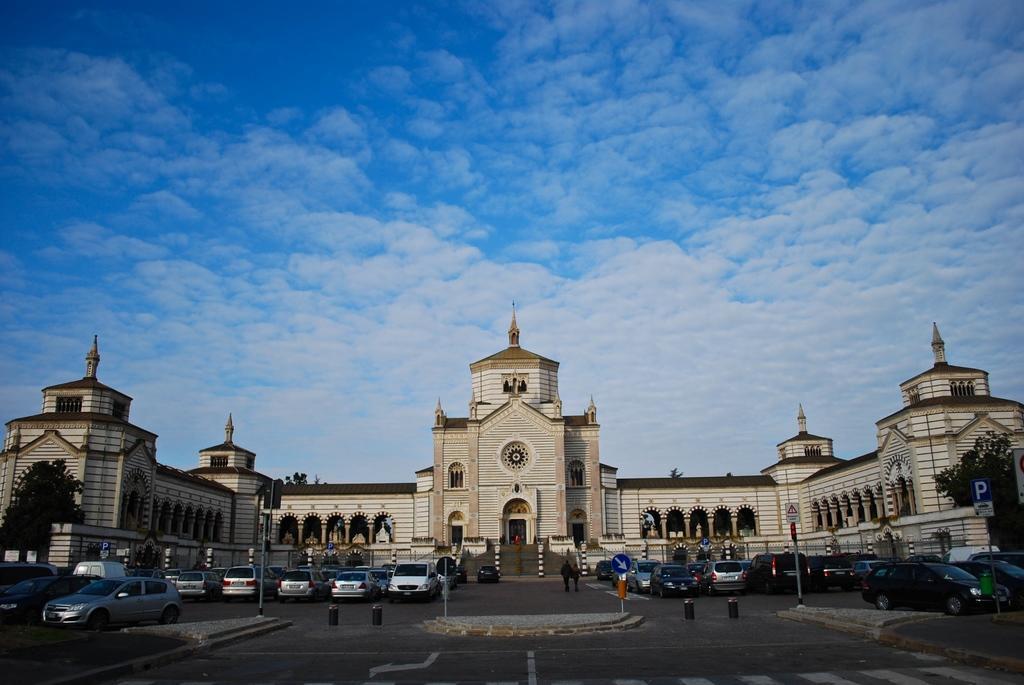Please provide a concise description of this image. In this image I can see few roads in the front and on it I can see number of vehicles, few poles, few sign boards and I can also see few people in the centre. In the background I can see a building and on the both side of this image I can see few trees. I can also see clouds and the sky in the background. 